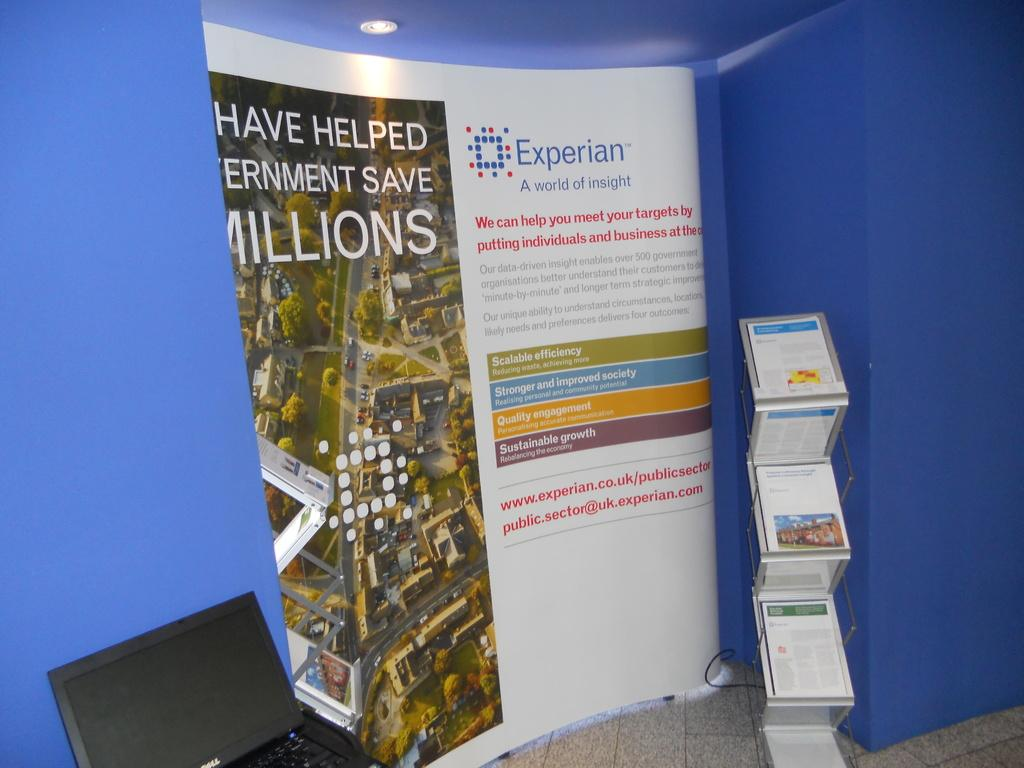<image>
Relay a brief, clear account of the picture shown. On a blue wall lies a poster advertised by Experian. 